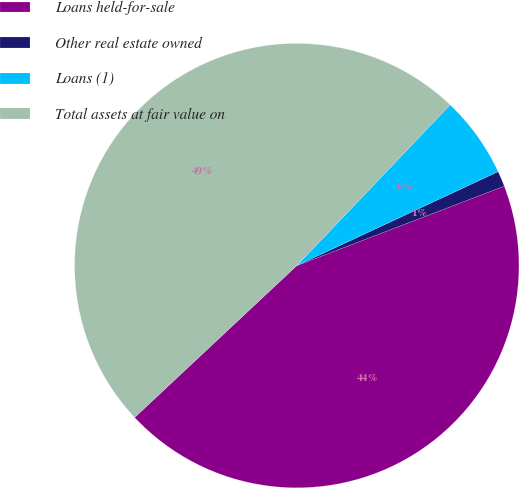Convert chart. <chart><loc_0><loc_0><loc_500><loc_500><pie_chart><fcel>Loans held-for-sale<fcel>Other real estate owned<fcel>Loans (1)<fcel>Total assets at fair value on<nl><fcel>43.84%<fcel>1.13%<fcel>5.93%<fcel>49.1%<nl></chart> 